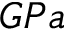<formula> <loc_0><loc_0><loc_500><loc_500>G P a</formula> 